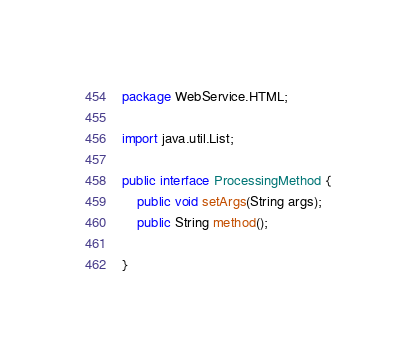<code> <loc_0><loc_0><loc_500><loc_500><_Java_>package WebService.HTML;

import java.util.List;

public interface ProcessingMethod {
	public void setArgs(String args);
	public String method();

}
</code> 